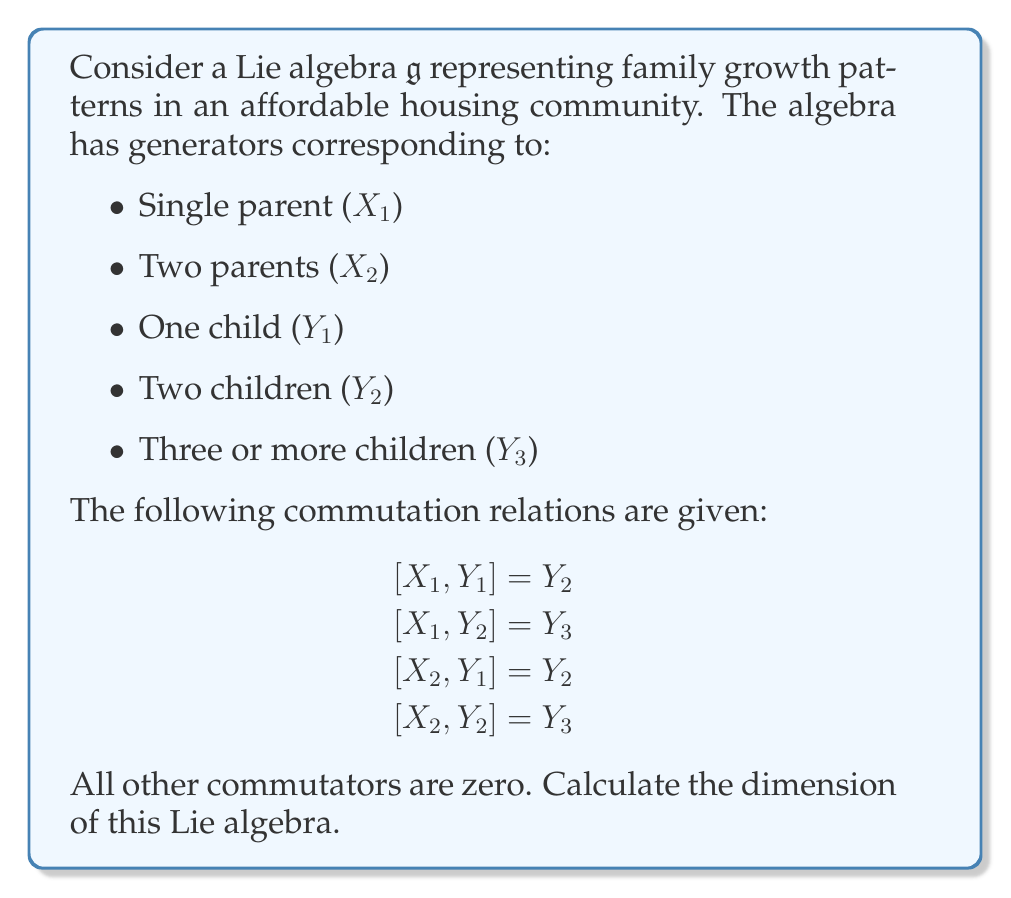Give your solution to this math problem. To calculate the dimension of the Lie algebra $\mathfrak{g}$, we need to count the number of linearly independent generators. Let's approach this step-by-step:

1) First, let's list all the generators we have:
   $X_1$, $X_2$, $Y_1$, $Y_2$, $Y_3$

2) These generators are all linearly independent because:
   a) $X_1$ and $X_2$ represent different family structures (single parent vs. two parents)
   b) $Y_1$, $Y_2$, and $Y_3$ represent different numbers of children
   c) The commutation relations don't create any linear dependencies among these generators

3) The commutation relations only show how these generators interact, but they don't introduce any new generators or create any linear dependencies.

4) Therefore, the dimension of the Lie algebra is simply the number of generators.

5) Counting the generators:
   2 parent-type generators ($X_1$, $X_2$)
   3 child-type generators ($Y_1$, $Y_2$, $Y_3$)
   
   Total: 2 + 3 = 5 generators

Thus, the dimension of the Lie algebra $\mathfrak{g}$ is 5.
Answer: The dimension of the Lie algebra $\mathfrak{g}$ is 5. 